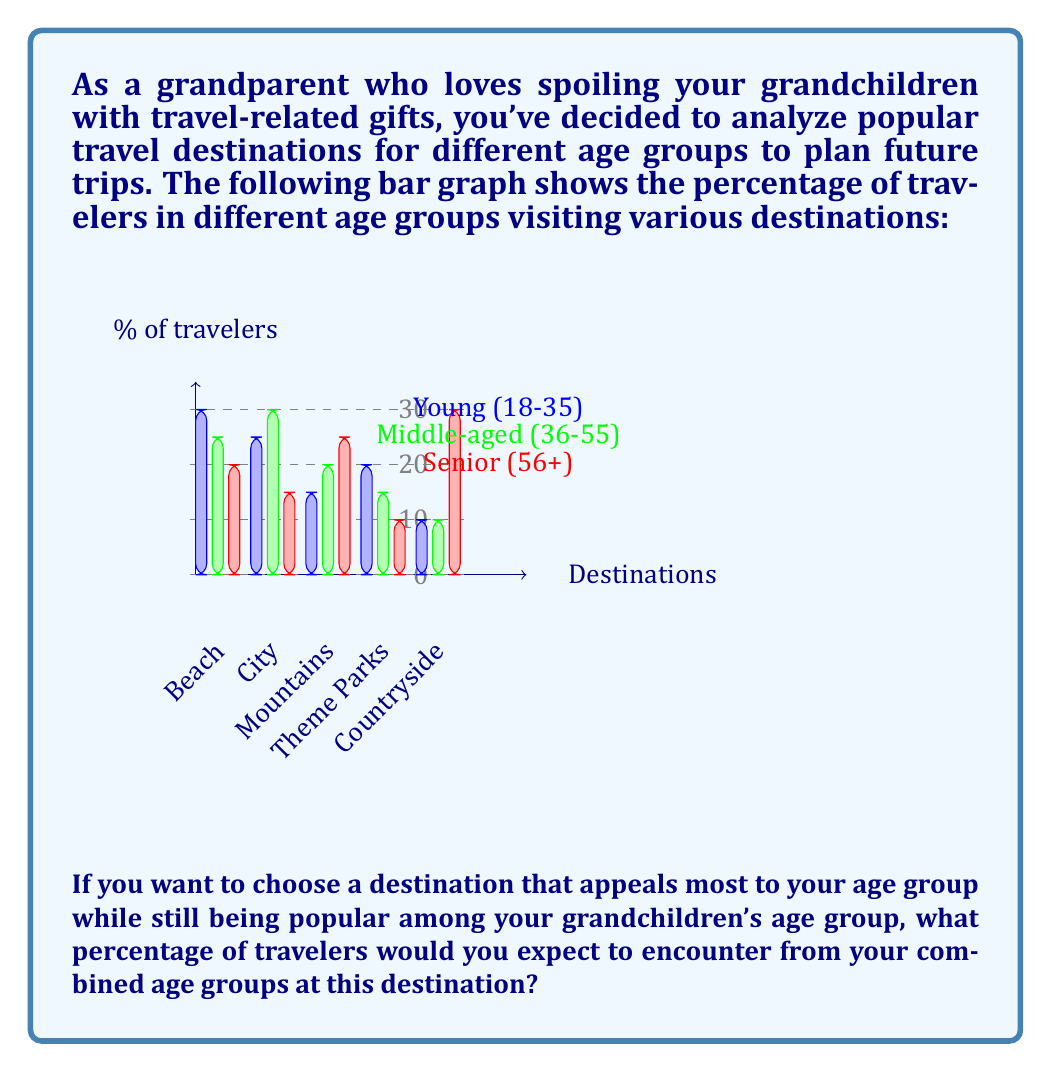Give your solution to this math problem. Let's approach this step-by-step:

1) First, we need to identify the age groups:
   - Grandparent: Senior (56+)
   - Grandchildren: Young (18-35)

2) Now, we need to find a destination that's popular for both age groups:
   - Beach: Senior 20%, Young 30%
   - City: Senior 15%, Young 25%
   - Mountains: Senior 25%, Young 15%
   - Theme Parks: Senior 10%, Young 20%
   - Countryside: Senior 30%, Young 10%

3) The destination with the highest combined percentage for both age groups is the Beach:
   Senior: 20%
   Young: 30%

4) To calculate the combined percentage:
   $$ \text{Combined Percentage} = 20\% + 30\% = 50\% $$

Therefore, at the Beach destination, you would expect 50% of travelers to be from your combined age groups.
Answer: 50% 